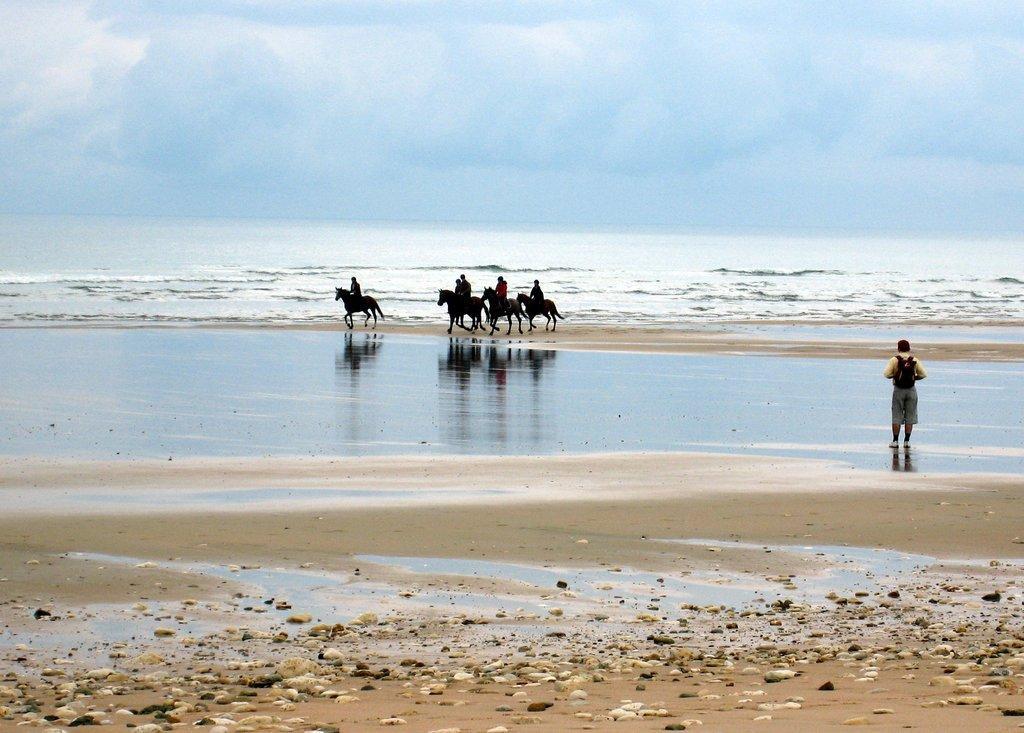Can you describe this image briefly? In this image there are few people riding horses on the seashore area and there is a person standing. In the background there is a river and the sky. 